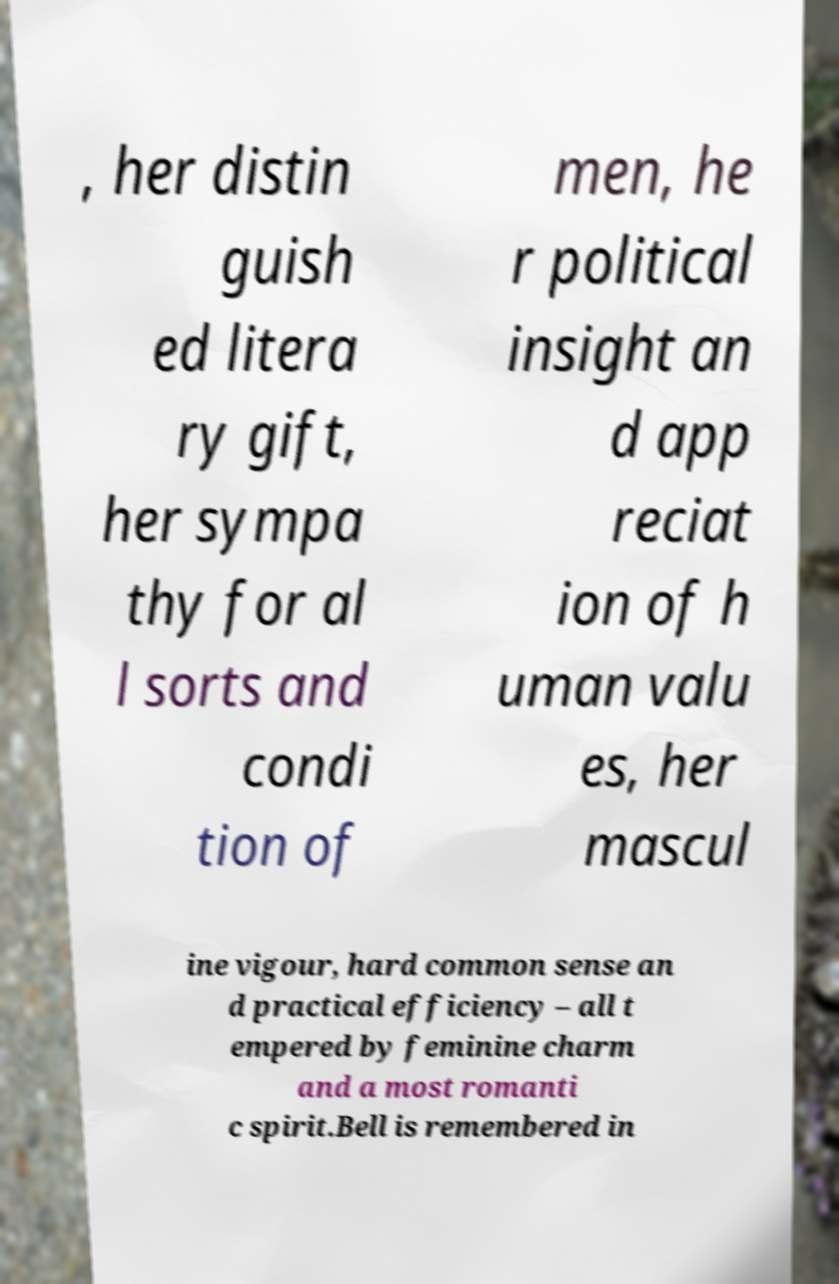Can you read and provide the text displayed in the image?This photo seems to have some interesting text. Can you extract and type it out for me? , her distin guish ed litera ry gift, her sympa thy for al l sorts and condi tion of men, he r political insight an d app reciat ion of h uman valu es, her mascul ine vigour, hard common sense an d practical efficiency – all t empered by feminine charm and a most romanti c spirit.Bell is remembered in 